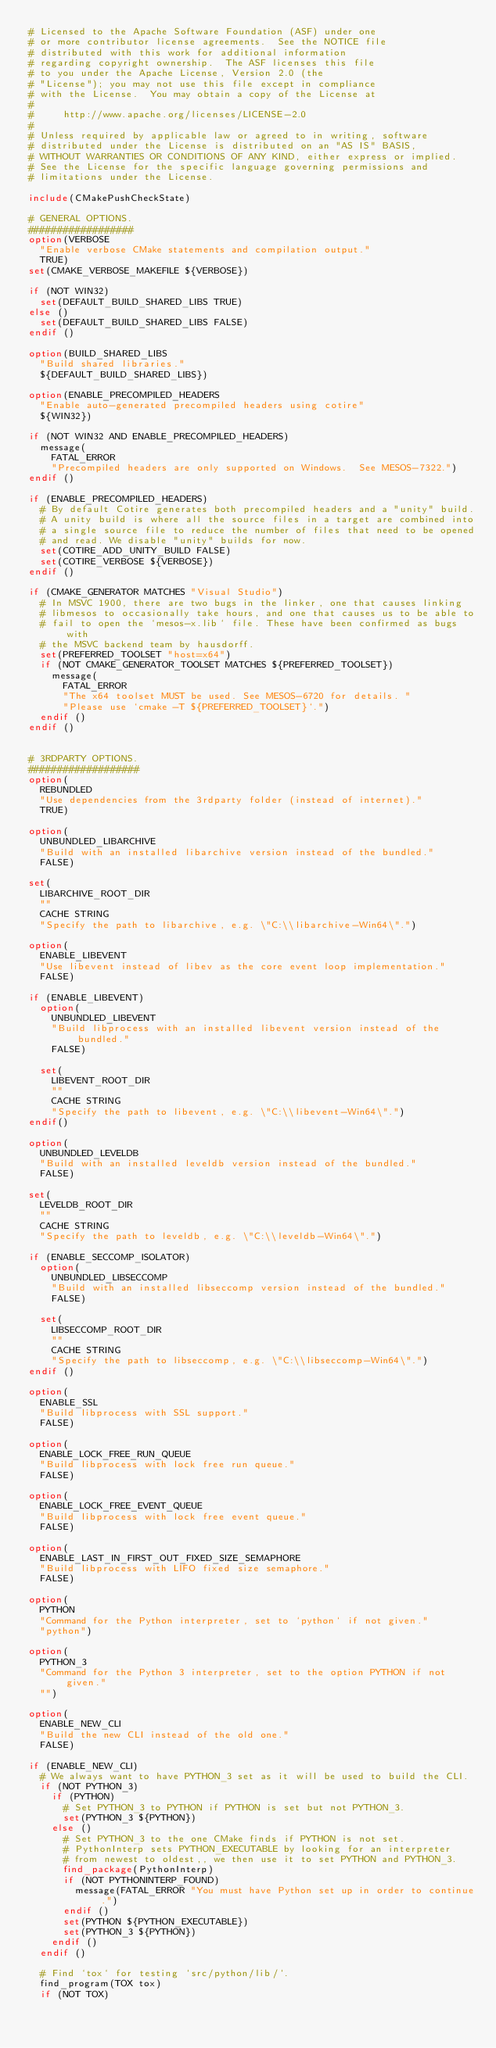Convert code to text. <code><loc_0><loc_0><loc_500><loc_500><_CMake_># Licensed to the Apache Software Foundation (ASF) under one
# or more contributor license agreements.  See the NOTICE file
# distributed with this work for additional information
# regarding copyright ownership.  The ASF licenses this file
# to you under the Apache License, Version 2.0 (the
# "License"); you may not use this file except in compliance
# with the License.  You may obtain a copy of the License at
#
#     http://www.apache.org/licenses/LICENSE-2.0
#
# Unless required by applicable law or agreed to in writing, software
# distributed under the License is distributed on an "AS IS" BASIS,
# WITHOUT WARRANTIES OR CONDITIONS OF ANY KIND, either express or implied.
# See the License for the specific language governing permissions and
# limitations under the License.

include(CMakePushCheckState)

# GENERAL OPTIONS.
##################
option(VERBOSE
  "Enable verbose CMake statements and compilation output."
  TRUE)
set(CMAKE_VERBOSE_MAKEFILE ${VERBOSE})

if (NOT WIN32)
  set(DEFAULT_BUILD_SHARED_LIBS TRUE)
else ()
  set(DEFAULT_BUILD_SHARED_LIBS FALSE)
endif ()

option(BUILD_SHARED_LIBS
  "Build shared libraries."
  ${DEFAULT_BUILD_SHARED_LIBS})

option(ENABLE_PRECOMPILED_HEADERS
  "Enable auto-generated precompiled headers using cotire"
  ${WIN32})

if (NOT WIN32 AND ENABLE_PRECOMPILED_HEADERS)
  message(
    FATAL_ERROR
    "Precompiled headers are only supported on Windows.  See MESOS-7322.")
endif ()

if (ENABLE_PRECOMPILED_HEADERS)
  # By default Cotire generates both precompiled headers and a "unity" build.
  # A unity build is where all the source files in a target are combined into
  # a single source file to reduce the number of files that need to be opened
  # and read. We disable "unity" builds for now.
  set(COTIRE_ADD_UNITY_BUILD FALSE)
  set(COTIRE_VERBOSE ${VERBOSE})
endif ()

if (CMAKE_GENERATOR MATCHES "Visual Studio")
  # In MSVC 1900, there are two bugs in the linker, one that causes linking
  # libmesos to occasionally take hours, and one that causes us to be able to
  # fail to open the `mesos-x.lib` file. These have been confirmed as bugs with
  # the MSVC backend team by hausdorff.
  set(PREFERRED_TOOLSET "host=x64")
  if (NOT CMAKE_GENERATOR_TOOLSET MATCHES ${PREFERRED_TOOLSET})
    message(
      FATAL_ERROR
      "The x64 toolset MUST be used. See MESOS-6720 for details. "
      "Please use `cmake -T ${PREFERRED_TOOLSET}`.")
  endif ()
endif ()


# 3RDPARTY OPTIONS.
###################
option(
  REBUNDLED
  "Use dependencies from the 3rdparty folder (instead of internet)."
  TRUE)

option(
  UNBUNDLED_LIBARCHIVE
  "Build with an installed libarchive version instead of the bundled."
  FALSE)

set(
  LIBARCHIVE_ROOT_DIR
  ""
  CACHE STRING
  "Specify the path to libarchive, e.g. \"C:\\libarchive-Win64\".")

option(
  ENABLE_LIBEVENT
  "Use libevent instead of libev as the core event loop implementation."
  FALSE)

if (ENABLE_LIBEVENT)
  option(
    UNBUNDLED_LIBEVENT
    "Build libprocess with an installed libevent version instead of the bundled."
    FALSE)

  set(
    LIBEVENT_ROOT_DIR
    ""
    CACHE STRING
    "Specify the path to libevent, e.g. \"C:\\libevent-Win64\".")
endif()

option(
  UNBUNDLED_LEVELDB
  "Build with an installed leveldb version instead of the bundled."
  FALSE)

set(
  LEVELDB_ROOT_DIR
  ""
  CACHE STRING
  "Specify the path to leveldb, e.g. \"C:\\leveldb-Win64\".")

if (ENABLE_SECCOMP_ISOLATOR)
  option(
    UNBUNDLED_LIBSECCOMP
    "Build with an installed libseccomp version instead of the bundled."
    FALSE)

  set(
    LIBSECCOMP_ROOT_DIR
    ""
    CACHE STRING
    "Specify the path to libseccomp, e.g. \"C:\\libseccomp-Win64\".")
endif ()

option(
  ENABLE_SSL
  "Build libprocess with SSL support."
  FALSE)

option(
  ENABLE_LOCK_FREE_RUN_QUEUE
  "Build libprocess with lock free run queue."
  FALSE)

option(
  ENABLE_LOCK_FREE_EVENT_QUEUE
  "Build libprocess with lock free event queue."
  FALSE)

option(
  ENABLE_LAST_IN_FIRST_OUT_FIXED_SIZE_SEMAPHORE
  "Build libprocess with LIFO fixed size semaphore."
  FALSE)

option(
  PYTHON
  "Command for the Python interpreter, set to `python` if not given."
  "python")

option(
  PYTHON_3
  "Command for the Python 3 interpreter, set to the option PYTHON if not given."
  "")

option(
  ENABLE_NEW_CLI
  "Build the new CLI instead of the old one."
  FALSE)

if (ENABLE_NEW_CLI)
  # We always want to have PYTHON_3 set as it will be used to build the CLI.
  if (NOT PYTHON_3)
    if (PYTHON)
      # Set PYTHON_3 to PYTHON if PYTHON is set but not PYTHON_3.
      set(PYTHON_3 ${PYTHON})
    else ()
      # Set PYTHON_3 to the one CMake finds if PYTHON is not set.
      # PythonInterp sets PYTHON_EXECUTABLE by looking for an interpreter
      # from newest to oldest,, we then use it to set PYTHON and PYTHON_3.
      find_package(PythonInterp)
      if (NOT PYTHONINTERP_FOUND)
        message(FATAL_ERROR "You must have Python set up in order to continue.")
      endif ()
      set(PYTHON ${PYTHON_EXECUTABLE})
      set(PYTHON_3 ${PYTHON})
    endif ()
  endif ()

  # Find `tox` for testing `src/python/lib/`.
  find_program(TOX tox)
  if (NOT TOX)</code> 